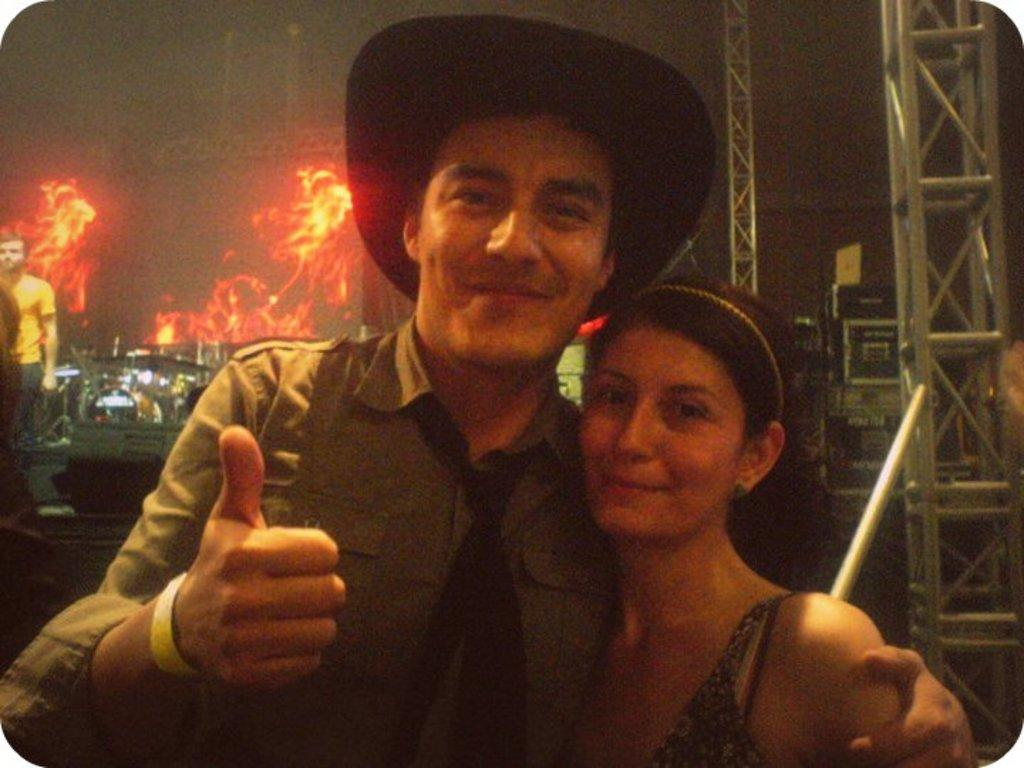How many people are present in the image? There are two people in the image, a man and a woman. What is the man wearing in the image? The man is wearing a hat in the image. What can be seen in the background of the image? There are lights visible in the background of the image. Is there anyone else present in the image besides the man and woman? Yes, there is a person standing in the background of the image. What type of yoke is being used by the man in the image? There is no yoke present in the image; the man is not using any such object. 